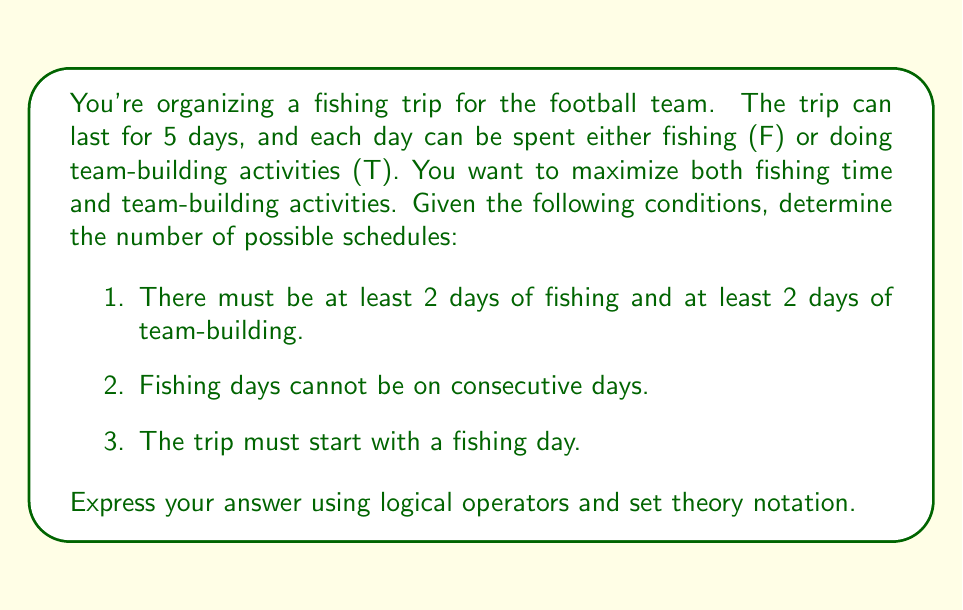Show me your answer to this math problem. Let's approach this step-by-step:

1) First, we know the trip must start with a fishing day (F). So our schedule will look like: F _ _ _ _

2) We need at least 2 days of fishing and 2 days of team-building. Given that we've already used one fishing day, we need at least 1 more F and 2 T's.

3) Fishing days cannot be consecutive. This means after the first F, we must have a T. So now our schedule looks like: F T _ _ _

4) We still need at least 1 more F and 1 more T. Let's consider the possible positions for the second F:

   - It can be in the 3rd position: F T F _ _
   - It can be in the 4th position: F T _ F _
   - It can be in the 5th position: F T _ _ F

5) For each of these cases, we need to fill the remaining positions with either F or T, ensuring we have at least 2 T's in total.

6) Let's count the possibilities for each case:
   
   Case 1 (F T F _ _): The last two days must be T T.
   Case 2 (F T _ F _): We can have T T F or T F T.
   Case 3 (F T _ _ F): We can have T T F or T F T.

7) In total, we have 1 + 2 + 2 = 5 possible schedules.

We can express this using set theory and logical operators:

Let $S$ be the set of all possible schedules.
Let $F_i$ be the event that day $i$ is a fishing day.
Let $T_i$ be the event that day $i$ is a team-building day.

Then:

$$S = \{s : (F_1 \land T_2 \land F_3 \land T_4 \land T_5) \lor$$
$$(F_1 \land T_2 \land T_3 \land F_4 \land T_5) \lor$$
$$(F_1 \land T_2 \land T_3 \land T_4 \land F_5) \lor$$
$$(F_1 \land T_2 \land T_3 \land F_4 \land T_5) \lor$$
$$(F_1 \land T_2 \land T_3 \land T_4 \land F_5)\}$$
Answer: $|S| = 5$, where $S$ is the set of all possible schedules satisfying the given conditions. 